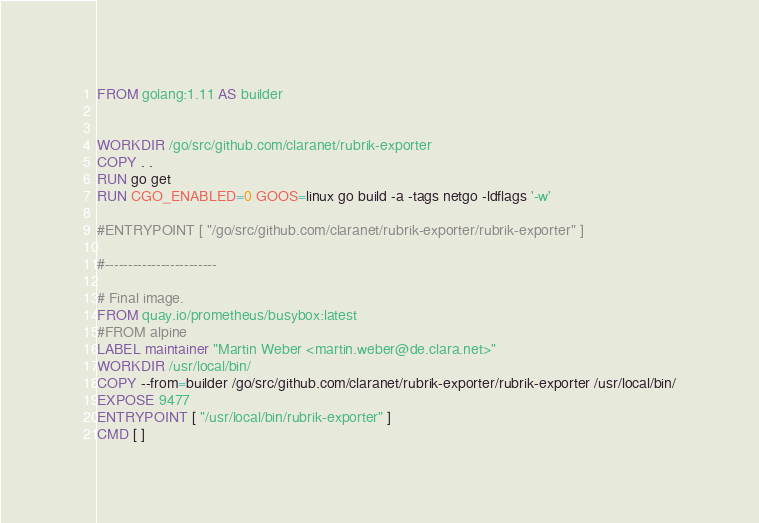<code> <loc_0><loc_0><loc_500><loc_500><_Dockerfile_>FROM golang:1.11 AS builder


WORKDIR /go/src/github.com/claranet/rubrik-exporter
COPY . .
RUN go get
RUN CGO_ENABLED=0 GOOS=linux go build -a -tags netgo -ldflags '-w'

#ENTRYPOINT [ "/go/src/github.com/claranet/rubrik-exporter/rubrik-exporter" ]

#------------------------

# Final image.
FROM quay.io/prometheus/busybox:latest
#FROM alpine
LABEL maintainer "Martin Weber <martin.weber@de.clara.net>"
WORKDIR /usr/local/bin/
COPY --from=builder /go/src/github.com/claranet/rubrik-exporter/rubrik-exporter /usr/local/bin/
EXPOSE 9477
ENTRYPOINT [ "/usr/local/bin/rubrik-exporter" ]
CMD [ ]
</code> 